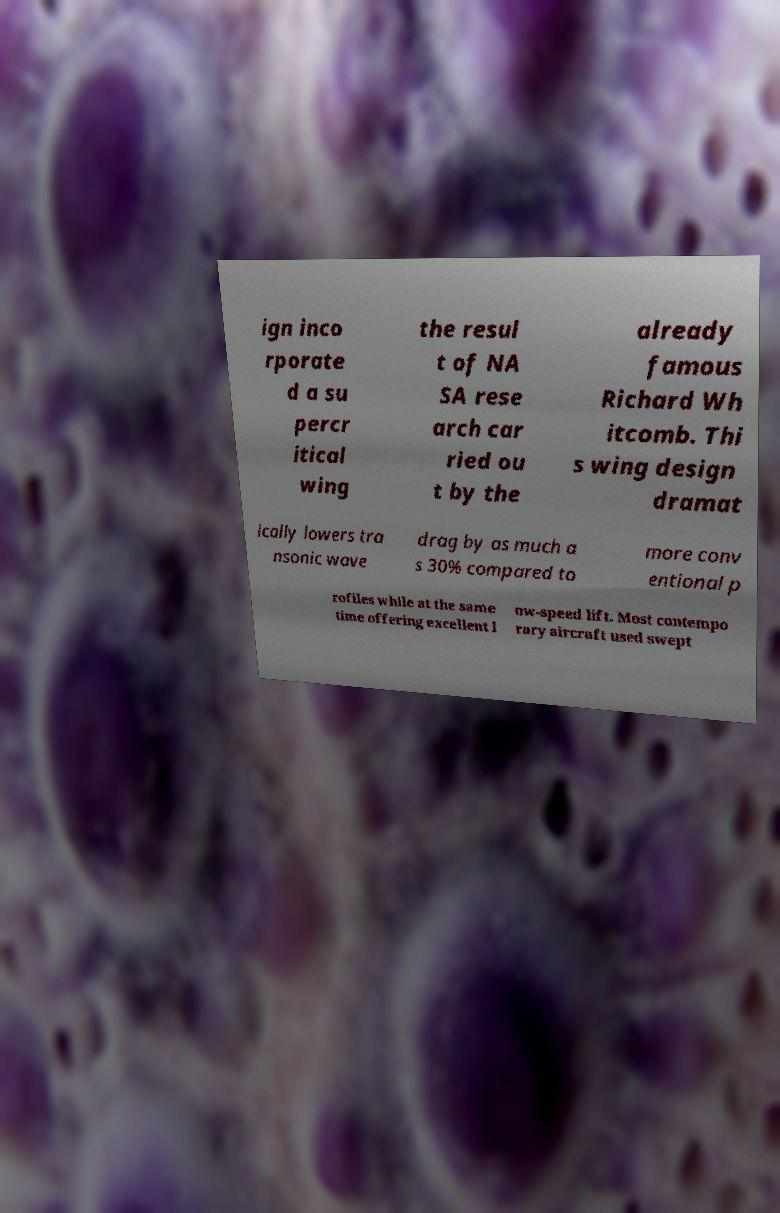Please identify and transcribe the text found in this image. ign inco rporate d a su percr itical wing the resul t of NA SA rese arch car ried ou t by the already famous Richard Wh itcomb. Thi s wing design dramat ically lowers tra nsonic wave drag by as much a s 30% compared to more conv entional p rofiles while at the same time offering excellent l ow-speed lift. Most contempo rary aircraft used swept 